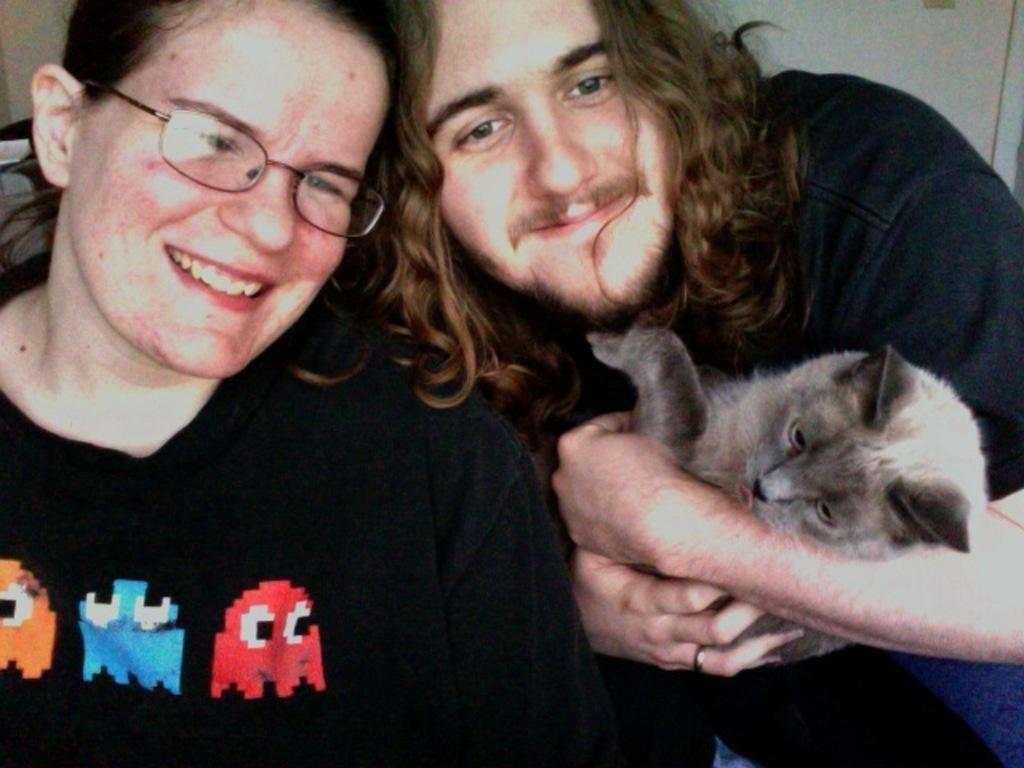What is the man doing on the right side of the image? The man is holding a cat on the right side of the image. What is the man's facial expression? The man is smiling in the image. What is the woman doing on the left side of the image? The woman is on the left side of the image. What is the woman wearing? The woman is wearing spectacles in the image. What is the woman's facial expression? The woman is smiling in the image. What type of stem can be seen growing from the cat's head in the image? There is no stem growing from the cat's head in the image; the cat is simply being held by the man. 